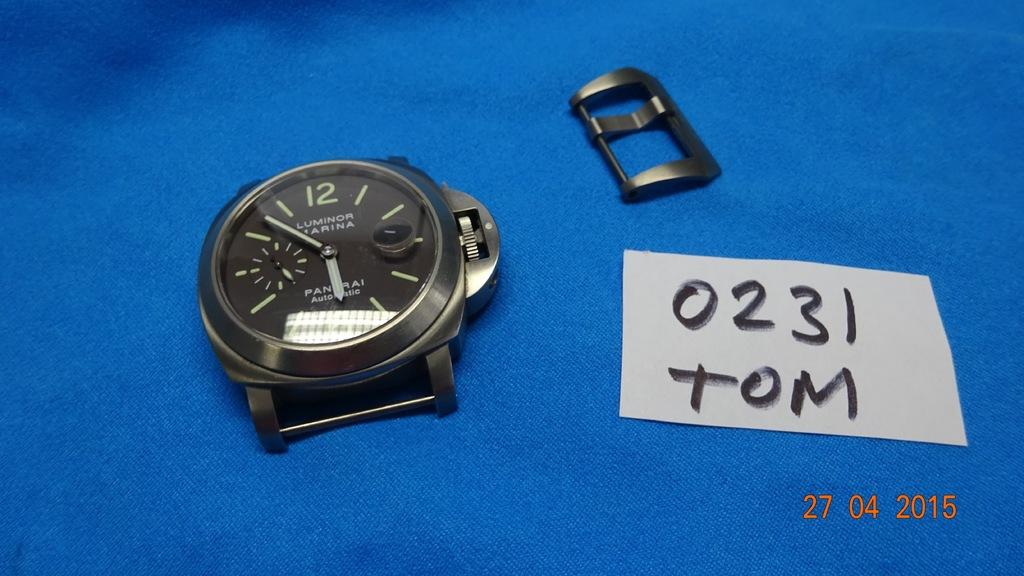<image>
Describe the image concisely. A Luminor watch sits next to a label that says 0231 TOM. 